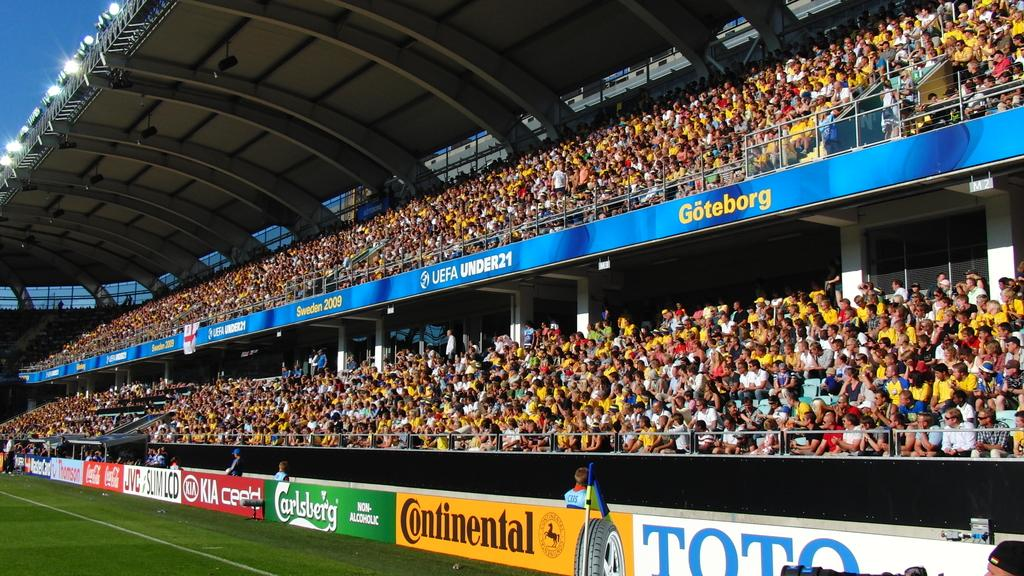<image>
Provide a brief description of the given image. The inside of a stadium with advertising from Continental and Carlsberg on the sidelines among others. 